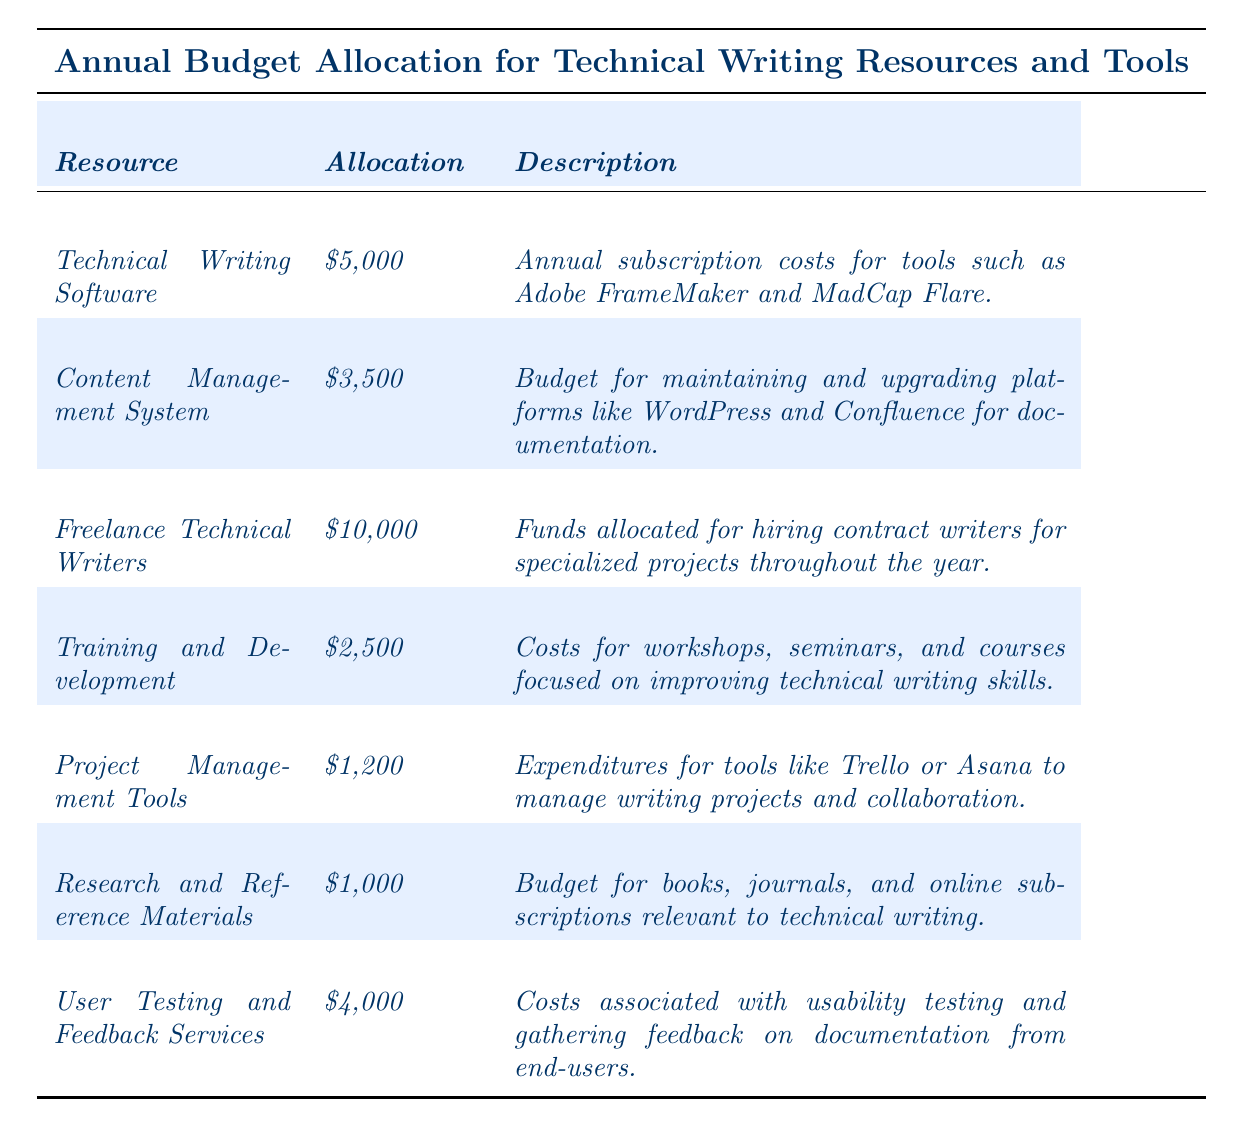What is the total annual budget allocation? By adding up the allocations for all resources: $5,000 + $3,500 + $10,000 + $2,500 + $1,200 + $1,000 + $4,000 = $27,200
Answer: $27,200 How much is allocated for freelance technical writers? The allocation for freelance technical writers is listed directly in the table as $10,000.
Answer: $10,000 Is the budget for user testing and feedback services higher than for training and development? Comparing the two allocations: $4,000 (user testing) is more than $2,500 (training), therefore the statement is true.
Answer: Yes What is the allocation for content management system in relation to the technical writing software? The content management system is allocated $3,500 and technical writing software is $5,000. To find the relation: $5,000 - $3,500 = $1,500, meaning technical writing software has $1,500 more.
Answer: $1,500 more What is the average budget allocation for all resources? There are 7 resources. First, calculate the total: $27,200. Then divide by the number of resources: $27,200 / 7 = $3,885.71.
Answer: $3,885.71 Are the expenses for research and reference materials less than the expenditures for project management tools? Research and reference materials are allocated $1,000, while project management tools are allocated $1,200. Since $1,000 is less than $1,200, the statement is true.
Answer: Yes What percentage of the total budget is allocated to training and development? The allocation for training and development is $2,500. To find the percentage, calculate: ($2,500 / $27,200) * 100 = 9.15%.
Answer: 9.15% Which resource has the highest budget allocation, and what is that amount? By reviewing the allocations, freelance technical writers have the highest allocation at $10,000.
Answer: $10,000 How much less is allocated to research and reference materials compared to the user testing and feedback services? Research and reference materials have an allocation of $1,000, and user testing services have $4,000. The difference is $4,000 - $1,000 = $3,000.
Answer: $3,000 If the budget for technical writing software increases by 10%, what will be the new allocation? The current allocation is $5,000. To calculate a 10% increase: $5,000 * 0.10 = $500. Adding this to the original amount gives $5,000 + $500 = $5,500.
Answer: $5,500 